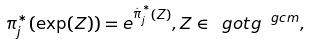<formula> <loc_0><loc_0><loc_500><loc_500>\pi ^ { * } _ { j } ( \exp ( Z ) ) = e ^ { \stackrel { . } { \pi } ^ { * } _ { j } ( Z ) } , Z \in \ g o t { g } ^ { \ g c m } ,</formula> 